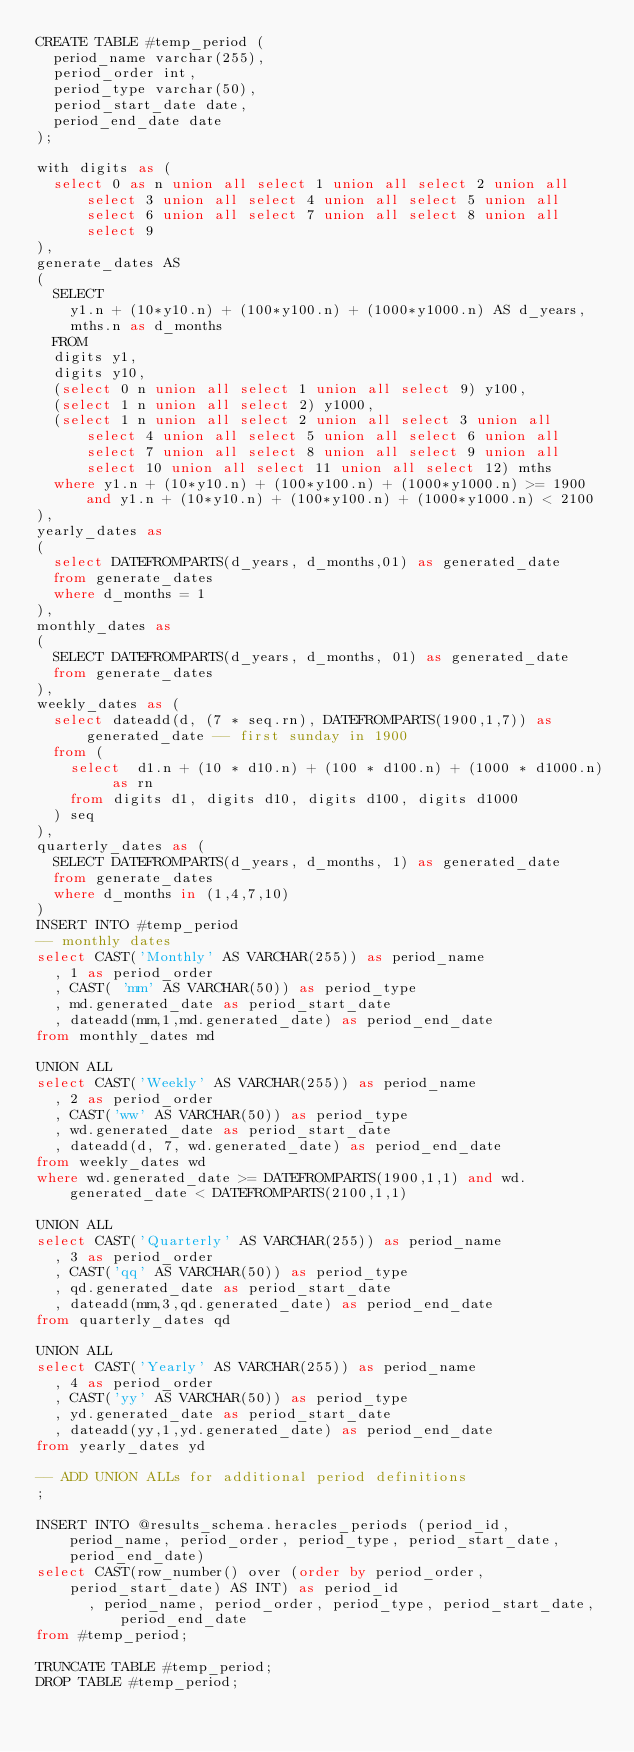<code> <loc_0><loc_0><loc_500><loc_500><_SQL_>CREATE TABLE #temp_period (
	period_name varchar(255),
  period_order int,
  period_type varchar(50),
	period_start_date date,
	period_end_date date
);

with digits as (
	select 0 as n union all select 1 union all select 2 union all select 3 union all select 4 union all select 5 union all select 6 union all select 7 union all select 8 union all select 9
),
generate_dates AS
(
	SELECT
		y1.n + (10*y10.n) + (100*y100.n) + (1000*y1000.n) AS d_years,
		mths.n as d_months
	FROM
	digits y1,
	digits y10,
	(select 0 n union all select 1 union all select 9) y100,
	(select 1 n union all select 2) y1000,
	(select 1 n union all select 2 union all select 3 union all select 4 union all select 5 union all select 6 union all select 7 union all select 8 union all select 9 union all select 10 union all select 11 union all select 12) mths
	where y1.n + (10*y10.n) + (100*y100.n) + (1000*y1000.n) >= 1900 and y1.n + (10*y10.n) + (100*y100.n) + (1000*y1000.n) < 2100
),
yearly_dates as
(
	select DATEFROMPARTS(d_years, d_months,01) as generated_date
	from generate_dates
  where d_months = 1
),
monthly_dates as
(
	SELECT DATEFROMPARTS(d_years, d_months, 01) as generated_date
	from generate_dates
),
weekly_dates as (
  select dateadd(d, (7 * seq.rn), DATEFROMPARTS(1900,1,7)) as generated_date -- first sunday in 1900
	from (
		select  d1.n + (10 * d10.n) + (100 * d100.n) + (1000 * d1000.n) as rn
		from digits d1, digits d10, digits d100, digits d1000
	) seq
),
quarterly_dates as (
  SELECT DATEFROMPARTS(d_years, d_months, 1) as generated_date
	from generate_dates
	where d_months in (1,4,7,10)
)
INSERT INTO #temp_period
-- monthly dates
select CAST('Monthly' AS VARCHAR(255)) as period_name
  , 1 as period_order
  , CAST( 'mm' AS VARCHAR(50)) as period_type
  , md.generated_date as period_start_date
  , dateadd(mm,1,md.generated_date) as period_end_date
from monthly_dates md

UNION ALL
select CAST('Weekly' AS VARCHAR(255)) as period_name
  , 2 as period_order
  , CAST('ww' AS VARCHAR(50)) as period_type
  , wd.generated_date as period_start_date
  , dateadd(d, 7, wd.generated_date) as period_end_date
from weekly_dates wd
where wd.generated_date >= DATEFROMPARTS(1900,1,1) and wd.generated_date < DATEFROMPARTS(2100,1,1)

UNION ALL
select CAST('Quarterly' AS VARCHAR(255)) as period_name
  , 3 as period_order
  , CAST('qq' AS VARCHAR(50)) as period_type
  , qd.generated_date as period_start_date
  , dateadd(mm,3,qd.generated_date) as period_end_date
from quarterly_dates qd

UNION ALL
select CAST('Yearly' AS VARCHAR(255)) as period_name
  , 4 as period_order
  , CAST('yy' AS VARCHAR(50)) as period_type
  , yd.generated_date as period_start_date
  , dateadd(yy,1,yd.generated_date) as period_end_date
from yearly_dates yd

-- ADD UNION ALLs for additional period definitions
;

INSERT INTO @results_schema.heracles_periods (period_id, period_name, period_order, period_type, period_start_date, period_end_date)
select CAST(row_number() over (order by period_order, period_start_date) AS INT) as period_id
			, period_name, period_order, period_type, period_start_date, period_end_date
from #temp_period;

TRUNCATE TABLE #temp_period;
DROP TABLE #temp_period;

</code> 